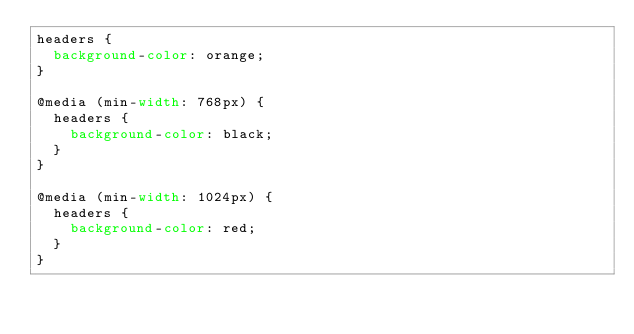Convert code to text. <code><loc_0><loc_0><loc_500><loc_500><_CSS_>headers {
  background-color: orange;
}

@media (min-width: 768px) {
  headers {
    background-color: black;
  }
}

@media (min-width: 1024px) {
  headers {
    background-color: red;
  }
}
</code> 